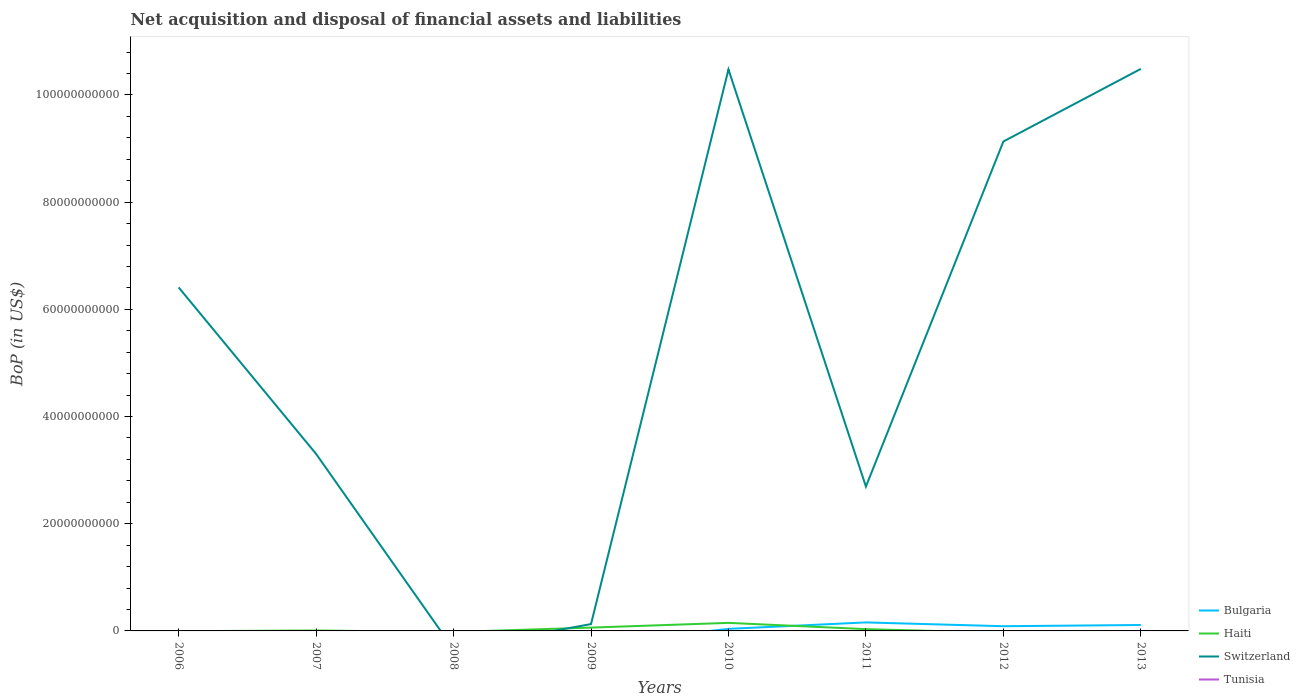How many different coloured lines are there?
Keep it short and to the point. 3. Does the line corresponding to Tunisia intersect with the line corresponding to Haiti?
Provide a short and direct response. No. What is the total Balance of Payments in Switzerland in the graph?
Make the answer very short. -2.72e+1. What is the difference between the highest and the second highest Balance of Payments in Bulgaria?
Your response must be concise. 1.59e+09. How many years are there in the graph?
Ensure brevity in your answer.  8. Are the values on the major ticks of Y-axis written in scientific E-notation?
Give a very brief answer. No. Does the graph contain any zero values?
Make the answer very short. Yes. Does the graph contain grids?
Your answer should be compact. No. How many legend labels are there?
Your answer should be very brief. 4. How are the legend labels stacked?
Give a very brief answer. Vertical. What is the title of the graph?
Your response must be concise. Net acquisition and disposal of financial assets and liabilities. Does "Botswana" appear as one of the legend labels in the graph?
Make the answer very short. No. What is the label or title of the Y-axis?
Provide a short and direct response. BoP (in US$). What is the BoP (in US$) in Bulgaria in 2006?
Ensure brevity in your answer.  0. What is the BoP (in US$) in Haiti in 2006?
Offer a very short reply. 0. What is the BoP (in US$) of Switzerland in 2006?
Your response must be concise. 6.41e+1. What is the BoP (in US$) in Tunisia in 2006?
Your answer should be compact. 0. What is the BoP (in US$) of Bulgaria in 2007?
Offer a terse response. 0. What is the BoP (in US$) of Haiti in 2007?
Offer a very short reply. 7.68e+07. What is the BoP (in US$) of Switzerland in 2007?
Make the answer very short. 3.30e+1. What is the BoP (in US$) in Haiti in 2008?
Offer a terse response. 0. What is the BoP (in US$) in Tunisia in 2008?
Your answer should be very brief. 0. What is the BoP (in US$) in Haiti in 2009?
Keep it short and to the point. 6.21e+08. What is the BoP (in US$) of Switzerland in 2009?
Make the answer very short. 1.28e+09. What is the BoP (in US$) in Bulgaria in 2010?
Your response must be concise. 3.84e+08. What is the BoP (in US$) of Haiti in 2010?
Give a very brief answer. 1.50e+09. What is the BoP (in US$) in Switzerland in 2010?
Ensure brevity in your answer.  1.05e+11. What is the BoP (in US$) in Bulgaria in 2011?
Provide a short and direct response. 1.59e+09. What is the BoP (in US$) of Haiti in 2011?
Your answer should be very brief. 3.34e+08. What is the BoP (in US$) of Switzerland in 2011?
Your answer should be compact. 2.69e+1. What is the BoP (in US$) in Bulgaria in 2012?
Provide a succinct answer. 8.77e+08. What is the BoP (in US$) of Haiti in 2012?
Give a very brief answer. 0. What is the BoP (in US$) in Switzerland in 2012?
Ensure brevity in your answer.  9.13e+1. What is the BoP (in US$) in Bulgaria in 2013?
Your answer should be compact. 1.11e+09. What is the BoP (in US$) of Haiti in 2013?
Keep it short and to the point. 0. What is the BoP (in US$) in Switzerland in 2013?
Provide a short and direct response. 1.05e+11. Across all years, what is the maximum BoP (in US$) in Bulgaria?
Your answer should be very brief. 1.59e+09. Across all years, what is the maximum BoP (in US$) of Haiti?
Offer a terse response. 1.50e+09. Across all years, what is the maximum BoP (in US$) of Switzerland?
Your answer should be compact. 1.05e+11. Across all years, what is the minimum BoP (in US$) of Bulgaria?
Your response must be concise. 0. Across all years, what is the minimum BoP (in US$) of Haiti?
Provide a short and direct response. 0. Across all years, what is the minimum BoP (in US$) of Switzerland?
Offer a terse response. 0. What is the total BoP (in US$) of Bulgaria in the graph?
Provide a succinct answer. 3.96e+09. What is the total BoP (in US$) of Haiti in the graph?
Keep it short and to the point. 2.53e+09. What is the total BoP (in US$) of Switzerland in the graph?
Make the answer very short. 4.26e+11. What is the total BoP (in US$) in Tunisia in the graph?
Make the answer very short. 0. What is the difference between the BoP (in US$) of Switzerland in 2006 and that in 2007?
Ensure brevity in your answer.  3.11e+1. What is the difference between the BoP (in US$) of Switzerland in 2006 and that in 2009?
Your answer should be compact. 6.28e+1. What is the difference between the BoP (in US$) of Switzerland in 2006 and that in 2010?
Give a very brief answer. -4.07e+1. What is the difference between the BoP (in US$) of Switzerland in 2006 and that in 2011?
Provide a succinct answer. 3.72e+1. What is the difference between the BoP (in US$) in Switzerland in 2006 and that in 2012?
Make the answer very short. -2.72e+1. What is the difference between the BoP (in US$) in Switzerland in 2006 and that in 2013?
Ensure brevity in your answer.  -4.08e+1. What is the difference between the BoP (in US$) in Haiti in 2007 and that in 2009?
Provide a succinct answer. -5.45e+08. What is the difference between the BoP (in US$) of Switzerland in 2007 and that in 2009?
Your answer should be compact. 3.18e+1. What is the difference between the BoP (in US$) of Haiti in 2007 and that in 2010?
Your answer should be compact. -1.42e+09. What is the difference between the BoP (in US$) in Switzerland in 2007 and that in 2010?
Offer a terse response. -7.17e+1. What is the difference between the BoP (in US$) in Haiti in 2007 and that in 2011?
Your response must be concise. -2.57e+08. What is the difference between the BoP (in US$) in Switzerland in 2007 and that in 2011?
Provide a short and direct response. 6.09e+09. What is the difference between the BoP (in US$) in Switzerland in 2007 and that in 2012?
Provide a succinct answer. -5.83e+1. What is the difference between the BoP (in US$) of Switzerland in 2007 and that in 2013?
Provide a succinct answer. -7.18e+1. What is the difference between the BoP (in US$) in Haiti in 2009 and that in 2010?
Make the answer very short. -8.79e+08. What is the difference between the BoP (in US$) in Switzerland in 2009 and that in 2010?
Your answer should be very brief. -1.03e+11. What is the difference between the BoP (in US$) of Haiti in 2009 and that in 2011?
Provide a succinct answer. 2.88e+08. What is the difference between the BoP (in US$) of Switzerland in 2009 and that in 2011?
Keep it short and to the point. -2.57e+1. What is the difference between the BoP (in US$) in Switzerland in 2009 and that in 2012?
Give a very brief answer. -9.00e+1. What is the difference between the BoP (in US$) of Switzerland in 2009 and that in 2013?
Provide a short and direct response. -1.04e+11. What is the difference between the BoP (in US$) in Bulgaria in 2010 and that in 2011?
Your answer should be very brief. -1.20e+09. What is the difference between the BoP (in US$) of Haiti in 2010 and that in 2011?
Ensure brevity in your answer.  1.17e+09. What is the difference between the BoP (in US$) of Switzerland in 2010 and that in 2011?
Provide a succinct answer. 7.78e+1. What is the difference between the BoP (in US$) of Bulgaria in 2010 and that in 2012?
Offer a terse response. -4.93e+08. What is the difference between the BoP (in US$) of Switzerland in 2010 and that in 2012?
Provide a short and direct response. 1.34e+1. What is the difference between the BoP (in US$) of Bulgaria in 2010 and that in 2013?
Provide a succinct answer. -7.23e+08. What is the difference between the BoP (in US$) in Switzerland in 2010 and that in 2013?
Give a very brief answer. -1.09e+08. What is the difference between the BoP (in US$) of Bulgaria in 2011 and that in 2012?
Your answer should be very brief. 7.10e+08. What is the difference between the BoP (in US$) of Switzerland in 2011 and that in 2012?
Provide a short and direct response. -6.44e+1. What is the difference between the BoP (in US$) of Bulgaria in 2011 and that in 2013?
Offer a very short reply. 4.80e+08. What is the difference between the BoP (in US$) in Switzerland in 2011 and that in 2013?
Offer a very short reply. -7.79e+1. What is the difference between the BoP (in US$) in Bulgaria in 2012 and that in 2013?
Offer a terse response. -2.30e+08. What is the difference between the BoP (in US$) in Switzerland in 2012 and that in 2013?
Ensure brevity in your answer.  -1.35e+1. What is the difference between the BoP (in US$) in Haiti in 2007 and the BoP (in US$) in Switzerland in 2009?
Make the answer very short. -1.20e+09. What is the difference between the BoP (in US$) in Haiti in 2007 and the BoP (in US$) in Switzerland in 2010?
Your answer should be compact. -1.05e+11. What is the difference between the BoP (in US$) of Haiti in 2007 and the BoP (in US$) of Switzerland in 2011?
Give a very brief answer. -2.69e+1. What is the difference between the BoP (in US$) in Haiti in 2007 and the BoP (in US$) in Switzerland in 2012?
Offer a very short reply. -9.12e+1. What is the difference between the BoP (in US$) in Haiti in 2007 and the BoP (in US$) in Switzerland in 2013?
Provide a succinct answer. -1.05e+11. What is the difference between the BoP (in US$) in Haiti in 2009 and the BoP (in US$) in Switzerland in 2010?
Provide a succinct answer. -1.04e+11. What is the difference between the BoP (in US$) in Haiti in 2009 and the BoP (in US$) in Switzerland in 2011?
Offer a very short reply. -2.63e+1. What is the difference between the BoP (in US$) in Haiti in 2009 and the BoP (in US$) in Switzerland in 2012?
Keep it short and to the point. -9.07e+1. What is the difference between the BoP (in US$) of Haiti in 2009 and the BoP (in US$) of Switzerland in 2013?
Provide a short and direct response. -1.04e+11. What is the difference between the BoP (in US$) of Bulgaria in 2010 and the BoP (in US$) of Haiti in 2011?
Offer a terse response. 5.04e+07. What is the difference between the BoP (in US$) of Bulgaria in 2010 and the BoP (in US$) of Switzerland in 2011?
Provide a succinct answer. -2.65e+1. What is the difference between the BoP (in US$) of Haiti in 2010 and the BoP (in US$) of Switzerland in 2011?
Your answer should be compact. -2.54e+1. What is the difference between the BoP (in US$) of Bulgaria in 2010 and the BoP (in US$) of Switzerland in 2012?
Your response must be concise. -9.09e+1. What is the difference between the BoP (in US$) in Haiti in 2010 and the BoP (in US$) in Switzerland in 2012?
Ensure brevity in your answer.  -8.98e+1. What is the difference between the BoP (in US$) in Bulgaria in 2010 and the BoP (in US$) in Switzerland in 2013?
Give a very brief answer. -1.04e+11. What is the difference between the BoP (in US$) in Haiti in 2010 and the BoP (in US$) in Switzerland in 2013?
Your response must be concise. -1.03e+11. What is the difference between the BoP (in US$) of Bulgaria in 2011 and the BoP (in US$) of Switzerland in 2012?
Offer a terse response. -8.97e+1. What is the difference between the BoP (in US$) in Haiti in 2011 and the BoP (in US$) in Switzerland in 2012?
Make the answer very short. -9.10e+1. What is the difference between the BoP (in US$) of Bulgaria in 2011 and the BoP (in US$) of Switzerland in 2013?
Your answer should be very brief. -1.03e+11. What is the difference between the BoP (in US$) of Haiti in 2011 and the BoP (in US$) of Switzerland in 2013?
Provide a succinct answer. -1.05e+11. What is the difference between the BoP (in US$) of Bulgaria in 2012 and the BoP (in US$) of Switzerland in 2013?
Your answer should be compact. -1.04e+11. What is the average BoP (in US$) in Bulgaria per year?
Provide a succinct answer. 4.94e+08. What is the average BoP (in US$) in Haiti per year?
Ensure brevity in your answer.  3.17e+08. What is the average BoP (in US$) in Switzerland per year?
Ensure brevity in your answer.  5.33e+1. What is the average BoP (in US$) in Tunisia per year?
Offer a terse response. 0. In the year 2007, what is the difference between the BoP (in US$) in Haiti and BoP (in US$) in Switzerland?
Provide a short and direct response. -3.29e+1. In the year 2009, what is the difference between the BoP (in US$) of Haiti and BoP (in US$) of Switzerland?
Your response must be concise. -6.54e+08. In the year 2010, what is the difference between the BoP (in US$) in Bulgaria and BoP (in US$) in Haiti?
Ensure brevity in your answer.  -1.12e+09. In the year 2010, what is the difference between the BoP (in US$) in Bulgaria and BoP (in US$) in Switzerland?
Provide a succinct answer. -1.04e+11. In the year 2010, what is the difference between the BoP (in US$) in Haiti and BoP (in US$) in Switzerland?
Offer a very short reply. -1.03e+11. In the year 2011, what is the difference between the BoP (in US$) of Bulgaria and BoP (in US$) of Haiti?
Provide a succinct answer. 1.25e+09. In the year 2011, what is the difference between the BoP (in US$) in Bulgaria and BoP (in US$) in Switzerland?
Provide a succinct answer. -2.53e+1. In the year 2011, what is the difference between the BoP (in US$) of Haiti and BoP (in US$) of Switzerland?
Your answer should be compact. -2.66e+1. In the year 2012, what is the difference between the BoP (in US$) in Bulgaria and BoP (in US$) in Switzerland?
Offer a terse response. -9.04e+1. In the year 2013, what is the difference between the BoP (in US$) of Bulgaria and BoP (in US$) of Switzerland?
Your answer should be very brief. -1.04e+11. What is the ratio of the BoP (in US$) of Switzerland in 2006 to that in 2007?
Offer a terse response. 1.94. What is the ratio of the BoP (in US$) of Switzerland in 2006 to that in 2009?
Your answer should be very brief. 50.27. What is the ratio of the BoP (in US$) of Switzerland in 2006 to that in 2010?
Offer a terse response. 0.61. What is the ratio of the BoP (in US$) of Switzerland in 2006 to that in 2011?
Your answer should be compact. 2.38. What is the ratio of the BoP (in US$) in Switzerland in 2006 to that in 2012?
Keep it short and to the point. 0.7. What is the ratio of the BoP (in US$) in Switzerland in 2006 to that in 2013?
Your response must be concise. 0.61. What is the ratio of the BoP (in US$) of Haiti in 2007 to that in 2009?
Your answer should be very brief. 0.12. What is the ratio of the BoP (in US$) of Switzerland in 2007 to that in 2009?
Make the answer very short. 25.9. What is the ratio of the BoP (in US$) in Haiti in 2007 to that in 2010?
Give a very brief answer. 0.05. What is the ratio of the BoP (in US$) of Switzerland in 2007 to that in 2010?
Ensure brevity in your answer.  0.32. What is the ratio of the BoP (in US$) of Haiti in 2007 to that in 2011?
Your answer should be very brief. 0.23. What is the ratio of the BoP (in US$) of Switzerland in 2007 to that in 2011?
Provide a succinct answer. 1.23. What is the ratio of the BoP (in US$) in Switzerland in 2007 to that in 2012?
Give a very brief answer. 0.36. What is the ratio of the BoP (in US$) in Switzerland in 2007 to that in 2013?
Offer a terse response. 0.31. What is the ratio of the BoP (in US$) in Haiti in 2009 to that in 2010?
Keep it short and to the point. 0.41. What is the ratio of the BoP (in US$) of Switzerland in 2009 to that in 2010?
Your response must be concise. 0.01. What is the ratio of the BoP (in US$) of Haiti in 2009 to that in 2011?
Your answer should be compact. 1.86. What is the ratio of the BoP (in US$) in Switzerland in 2009 to that in 2011?
Provide a succinct answer. 0.05. What is the ratio of the BoP (in US$) of Switzerland in 2009 to that in 2012?
Your answer should be very brief. 0.01. What is the ratio of the BoP (in US$) of Switzerland in 2009 to that in 2013?
Offer a very short reply. 0.01. What is the ratio of the BoP (in US$) of Bulgaria in 2010 to that in 2011?
Your answer should be very brief. 0.24. What is the ratio of the BoP (in US$) of Haiti in 2010 to that in 2011?
Make the answer very short. 4.5. What is the ratio of the BoP (in US$) of Switzerland in 2010 to that in 2011?
Offer a terse response. 3.89. What is the ratio of the BoP (in US$) in Bulgaria in 2010 to that in 2012?
Make the answer very short. 0.44. What is the ratio of the BoP (in US$) in Switzerland in 2010 to that in 2012?
Offer a very short reply. 1.15. What is the ratio of the BoP (in US$) in Bulgaria in 2010 to that in 2013?
Keep it short and to the point. 0.35. What is the ratio of the BoP (in US$) in Switzerland in 2010 to that in 2013?
Offer a terse response. 1. What is the ratio of the BoP (in US$) of Bulgaria in 2011 to that in 2012?
Give a very brief answer. 1.81. What is the ratio of the BoP (in US$) of Switzerland in 2011 to that in 2012?
Your answer should be compact. 0.29. What is the ratio of the BoP (in US$) of Bulgaria in 2011 to that in 2013?
Provide a succinct answer. 1.43. What is the ratio of the BoP (in US$) in Switzerland in 2011 to that in 2013?
Offer a terse response. 0.26. What is the ratio of the BoP (in US$) in Bulgaria in 2012 to that in 2013?
Offer a very short reply. 0.79. What is the ratio of the BoP (in US$) in Switzerland in 2012 to that in 2013?
Your response must be concise. 0.87. What is the difference between the highest and the second highest BoP (in US$) in Bulgaria?
Your answer should be compact. 4.80e+08. What is the difference between the highest and the second highest BoP (in US$) of Haiti?
Your answer should be very brief. 8.79e+08. What is the difference between the highest and the second highest BoP (in US$) in Switzerland?
Your answer should be very brief. 1.09e+08. What is the difference between the highest and the lowest BoP (in US$) in Bulgaria?
Your response must be concise. 1.59e+09. What is the difference between the highest and the lowest BoP (in US$) of Haiti?
Your answer should be compact. 1.50e+09. What is the difference between the highest and the lowest BoP (in US$) in Switzerland?
Keep it short and to the point. 1.05e+11. 